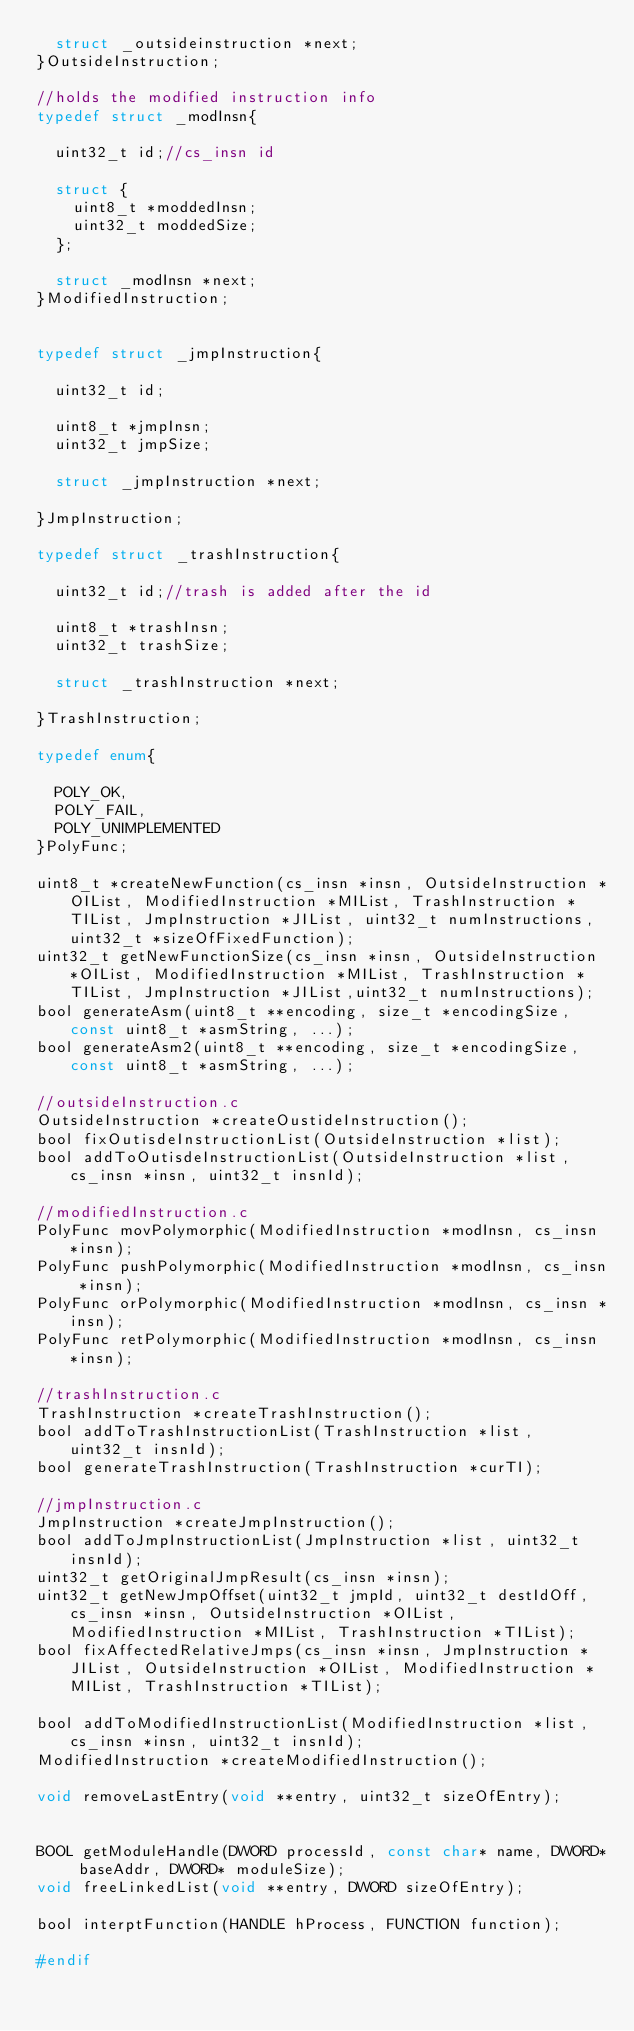<code> <loc_0><loc_0><loc_500><loc_500><_C_>	struct _outsideinstruction *next;
}OutsideInstruction;

//holds the modified instruction info
typedef struct _modInsn{
	
	uint32_t id;//cs_insn id
	
	struct {
		uint8_t *moddedInsn;
		uint32_t moddedSize;
	};
	
	struct _modInsn *next;
}ModifiedInstruction;


typedef struct _jmpInstruction{
	
	uint32_t id;
	
	uint8_t *jmpInsn;
	uint32_t jmpSize;
	
	struct _jmpInstruction *next;
	
}JmpInstruction;

typedef struct _trashInstruction{
	
	uint32_t id;//trash is added after the id
	
	uint8_t *trashInsn;
	uint32_t trashSize;
	
	struct _trashInstruction *next;
	
}TrashInstruction;

typedef enum{
	
	POLY_OK,
	POLY_FAIL,
	POLY_UNIMPLEMENTED
}PolyFunc;

uint8_t *createNewFunction(cs_insn *insn, OutsideInstruction *OIList, ModifiedInstruction *MIList, TrashInstruction *TIList, JmpInstruction *JIList, uint32_t numInstructions,uint32_t *sizeOfFixedFunction);
uint32_t getNewFunctionSize(cs_insn *insn, OutsideInstruction *OIList, ModifiedInstruction *MIList, TrashInstruction *TIList, JmpInstruction *JIList,uint32_t numInstructions);
bool generateAsm(uint8_t **encoding, size_t *encodingSize, const uint8_t *asmString, ...);
bool generateAsm2(uint8_t **encoding, size_t *encodingSize, const uint8_t *asmString, ...);

//outsideInstruction.c
OutsideInstruction *createOustideInstruction();
bool fixOutisdeInstructionList(OutsideInstruction *list);
bool addToOutisdeInstructionList(OutsideInstruction *list, cs_insn *insn, uint32_t insnId);

//modifiedInstruction.c
PolyFunc movPolymorphic(ModifiedInstruction *modInsn, cs_insn *insn);
PolyFunc pushPolymorphic(ModifiedInstruction *modInsn, cs_insn *insn);
PolyFunc orPolymorphic(ModifiedInstruction *modInsn, cs_insn *insn);
PolyFunc retPolymorphic(ModifiedInstruction *modInsn, cs_insn *insn);

//trashInstruction.c
TrashInstruction *createTrashInstruction();
bool addToTrashInstructionList(TrashInstruction *list, uint32_t insnId);
bool generateTrashInstruction(TrashInstruction *curTI);

//jmpInstruction.c
JmpInstruction *createJmpInstruction();
bool addToJmpInstructionList(JmpInstruction *list, uint32_t insnId);
uint32_t getOriginalJmpResult(cs_insn *insn);
uint32_t getNewJmpOffset(uint32_t jmpId, uint32_t destIdOff, cs_insn *insn, OutsideInstruction *OIList, ModifiedInstruction *MIList, TrashInstruction *TIList);
bool fixAffectedRelativeJmps(cs_insn *insn, JmpInstruction *JIList, OutsideInstruction *OIList, ModifiedInstruction *MIList, TrashInstruction *TIList);

bool addToModifiedInstructionList(ModifiedInstruction *list, cs_insn *insn, uint32_t insnId);
ModifiedInstruction *createModifiedInstruction();

void removeLastEntry(void **entry, uint32_t sizeOfEntry);


BOOL getModuleHandle(DWORD processId, const char* name, DWORD* baseAddr, DWORD* moduleSize);
void freeLinkedList(void **entry, DWORD sizeOfEntry);

bool interptFunction(HANDLE hProcess, FUNCTION function);

#endif</code> 